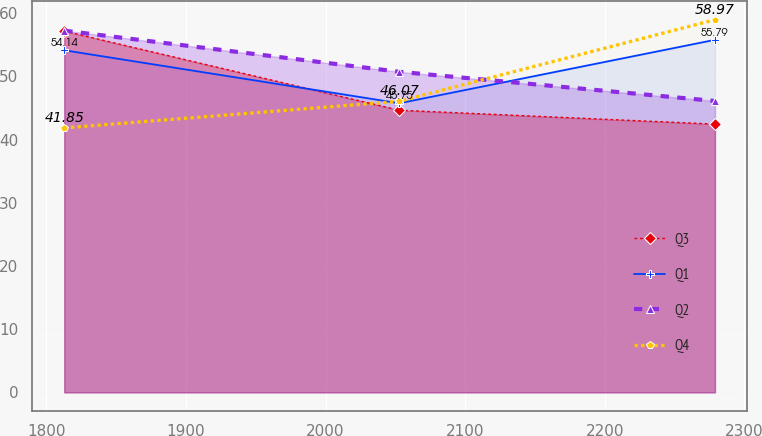<chart> <loc_0><loc_0><loc_500><loc_500><line_chart><ecel><fcel>Q3<fcel>Q1<fcel>Q2<fcel>Q4<nl><fcel>1812.9<fcel>57.17<fcel>54.14<fcel>57.24<fcel>41.85<nl><fcel>2052.86<fcel>44.65<fcel>45.75<fcel>50.73<fcel>46.07<nl><fcel>2278.88<fcel>42.45<fcel>55.79<fcel>46.11<fcel>58.97<nl></chart> 